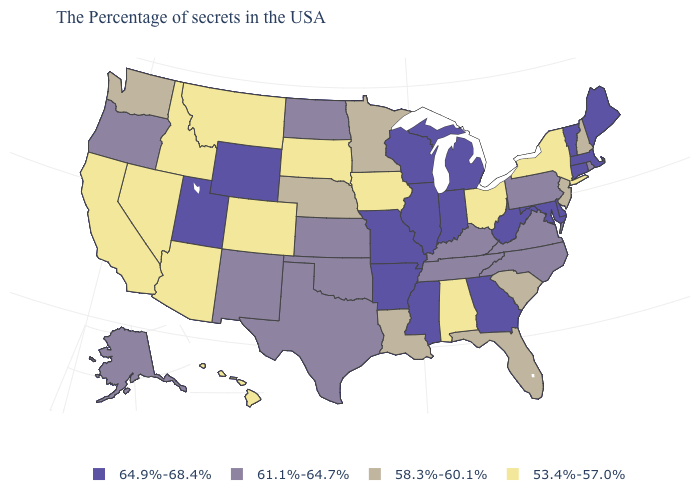Name the states that have a value in the range 58.3%-60.1%?
Keep it brief. New Hampshire, New Jersey, South Carolina, Florida, Louisiana, Minnesota, Nebraska, Washington. What is the value of Tennessee?
Write a very short answer. 61.1%-64.7%. How many symbols are there in the legend?
Keep it brief. 4. Name the states that have a value in the range 58.3%-60.1%?
Be succinct. New Hampshire, New Jersey, South Carolina, Florida, Louisiana, Minnesota, Nebraska, Washington. What is the highest value in the South ?
Quick response, please. 64.9%-68.4%. How many symbols are there in the legend?
Quick response, please. 4. What is the highest value in states that border Michigan?
Answer briefly. 64.9%-68.4%. Name the states that have a value in the range 61.1%-64.7%?
Quick response, please. Rhode Island, Pennsylvania, Virginia, North Carolina, Kentucky, Tennessee, Kansas, Oklahoma, Texas, North Dakota, New Mexico, Oregon, Alaska. What is the value of Alaska?
Answer briefly. 61.1%-64.7%. Name the states that have a value in the range 64.9%-68.4%?
Quick response, please. Maine, Massachusetts, Vermont, Connecticut, Delaware, Maryland, West Virginia, Georgia, Michigan, Indiana, Wisconsin, Illinois, Mississippi, Missouri, Arkansas, Wyoming, Utah. What is the value of South Carolina?
Answer briefly. 58.3%-60.1%. Which states hav the highest value in the South?
Concise answer only. Delaware, Maryland, West Virginia, Georgia, Mississippi, Arkansas. Name the states that have a value in the range 64.9%-68.4%?
Concise answer only. Maine, Massachusetts, Vermont, Connecticut, Delaware, Maryland, West Virginia, Georgia, Michigan, Indiana, Wisconsin, Illinois, Mississippi, Missouri, Arkansas, Wyoming, Utah. Does Vermont have the highest value in the Northeast?
Give a very brief answer. Yes. Name the states that have a value in the range 61.1%-64.7%?
Give a very brief answer. Rhode Island, Pennsylvania, Virginia, North Carolina, Kentucky, Tennessee, Kansas, Oklahoma, Texas, North Dakota, New Mexico, Oregon, Alaska. 